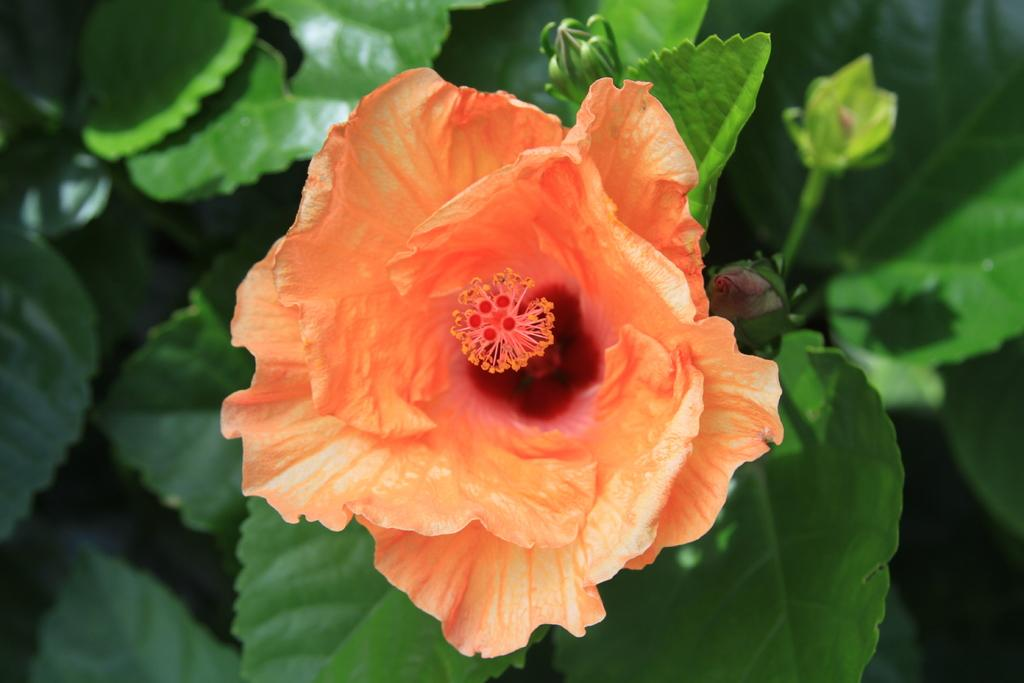What is the main subject of the image? There is a flower in the image. What color is the flower? The flower is orange in color. What can be seen below the flower? There are green leaves below the flower. What type of quarter is depicted in the image? There is no quarter present in the image; it features a flower with orange petals and green leaves. What kind of coat is the flower wearing in the image? Flowers do not wear coats, so this question cannot be answered. 